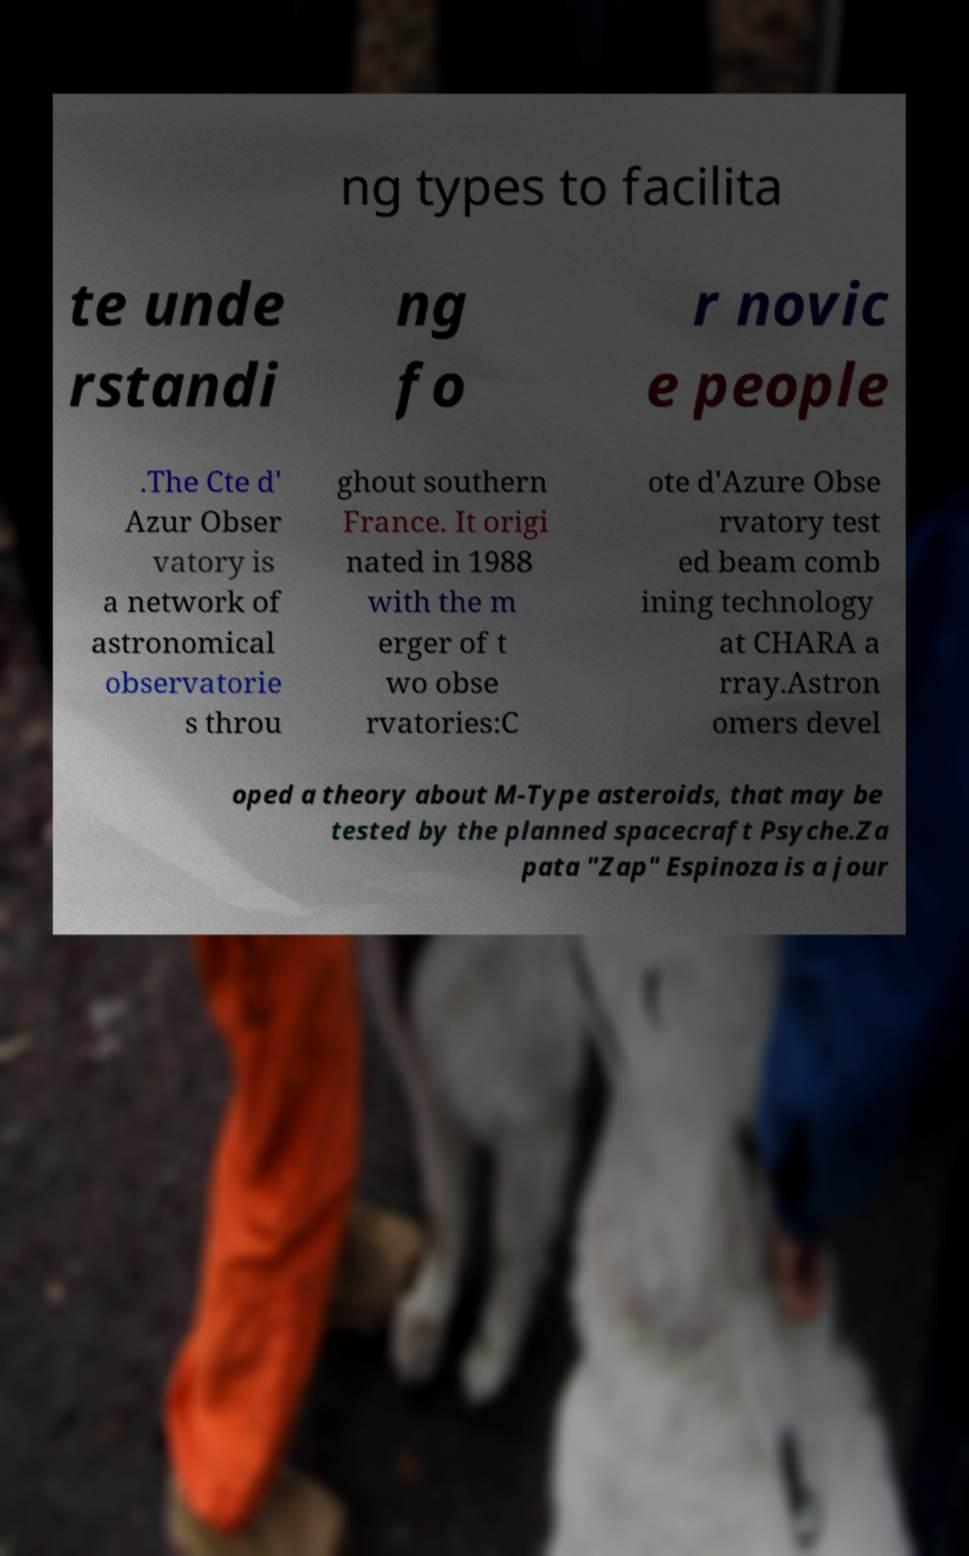For documentation purposes, I need the text within this image transcribed. Could you provide that? ng types to facilita te unde rstandi ng fo r novic e people .The Cte d' Azur Obser vatory is a network of astronomical observatorie s throu ghout southern France. It origi nated in 1988 with the m erger of t wo obse rvatories:C ote d'Azure Obse rvatory test ed beam comb ining technology at CHARA a rray.Astron omers devel oped a theory about M-Type asteroids, that may be tested by the planned spacecraft Psyche.Za pata "Zap" Espinoza is a jour 